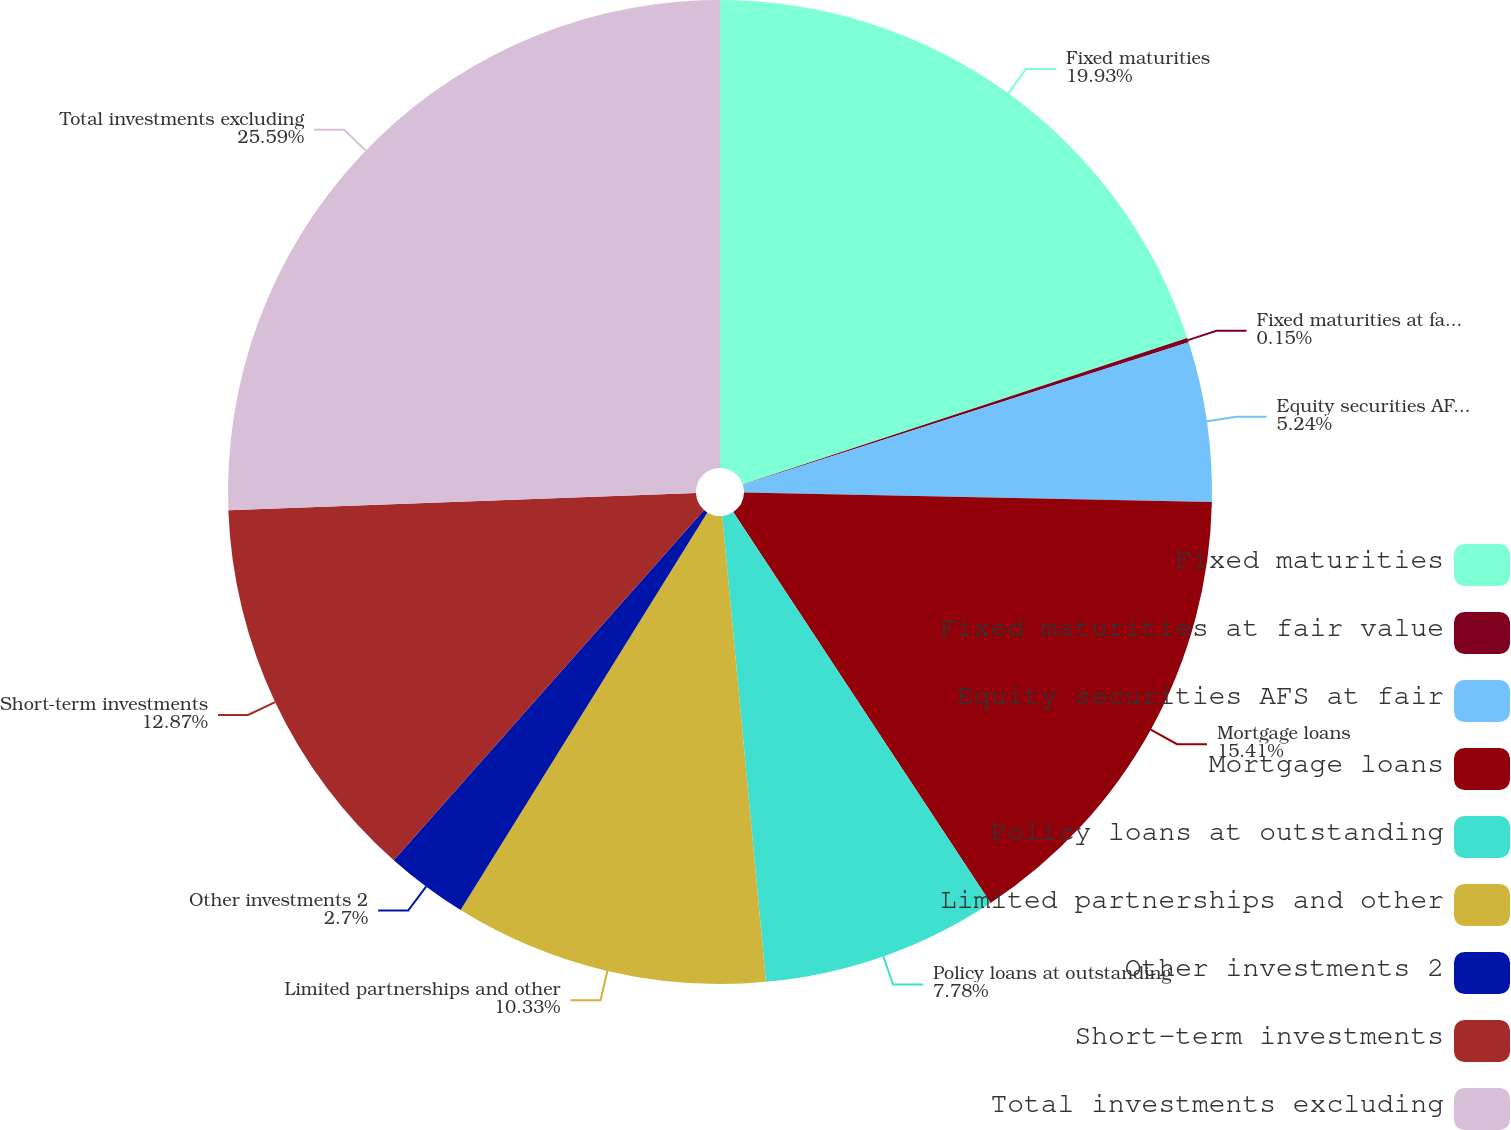Convert chart to OTSL. <chart><loc_0><loc_0><loc_500><loc_500><pie_chart><fcel>Fixed maturities<fcel>Fixed maturities at fair value<fcel>Equity securities AFS at fair<fcel>Mortgage loans<fcel>Policy loans at outstanding<fcel>Limited partnerships and other<fcel>Other investments 2<fcel>Short-term investments<fcel>Total investments excluding<nl><fcel>19.93%<fcel>0.15%<fcel>5.24%<fcel>15.41%<fcel>7.78%<fcel>10.33%<fcel>2.7%<fcel>12.87%<fcel>25.59%<nl></chart> 